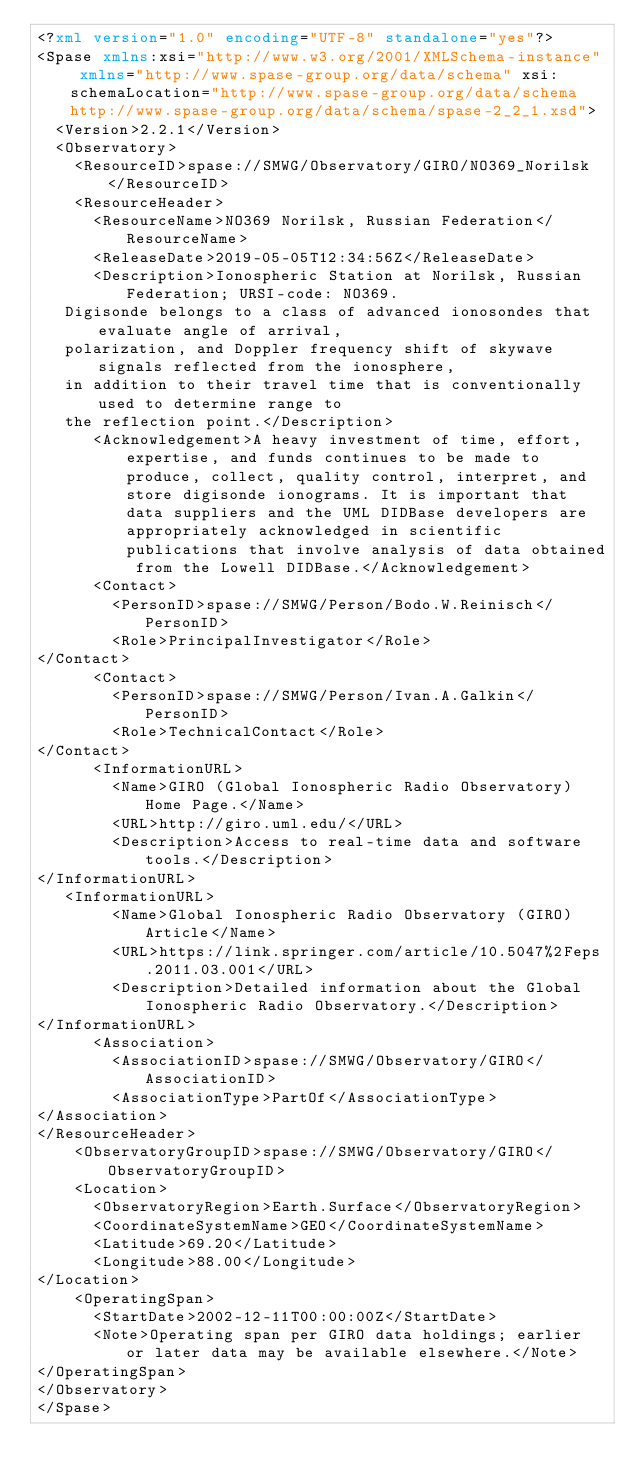<code> <loc_0><loc_0><loc_500><loc_500><_XML_><?xml version="1.0" encoding="UTF-8" standalone="yes"?>
<Spase xmlns:xsi="http://www.w3.org/2001/XMLSchema-instance" xmlns="http://www.spase-group.org/data/schema" xsi:schemaLocation="http://www.spase-group.org/data/schema http://www.spase-group.org/data/schema/spase-2_2_1.xsd">
  <Version>2.2.1</Version>
  <Observatory>
    <ResourceID>spase://SMWG/Observatory/GIRO/NO369_Norilsk</ResourceID>
    <ResourceHeader>
      <ResourceName>NO369 Norilsk, Russian Federation</ResourceName>
      <ReleaseDate>2019-05-05T12:34:56Z</ReleaseDate>
      <Description>Ionospheric Station at Norilsk, Russian Federation; URSI-code: NO369.
   Digisonde belongs to a class of advanced ionosondes that evaluate angle of arrival,
   polarization, and Doppler frequency shift of skywave signals reflected from the ionosphere,
   in addition to their travel time that is conventionally used to determine range to
   the reflection point.</Description>
      <Acknowledgement>A heavy investment of time, effort, expertise, and funds continues to be made to produce, collect, quality control, interpret, and store digisonde ionograms. It is important that data suppliers and the UML DIDBase developers are appropriately acknowledged in scientific publications that involve analysis of data obtained from the Lowell DIDBase.</Acknowledgement>
      <Contact>
        <PersonID>spase://SMWG/Person/Bodo.W.Reinisch</PersonID>
        <Role>PrincipalInvestigator</Role>
</Contact>
      <Contact>
        <PersonID>spase://SMWG/Person/Ivan.A.Galkin</PersonID>
        <Role>TechnicalContact</Role>
</Contact>
      <InformationURL>
        <Name>GIRO (Global Ionospheric Radio Observatory) Home Page.</Name>
        <URL>http://giro.uml.edu/</URL>
        <Description>Access to real-time data and software tools.</Description>
</InformationURL>
   <InformationURL>
        <Name>Global Ionospheric Radio Observatory (GIRO) Article</Name>
        <URL>https://link.springer.com/article/10.5047%2Feps.2011.03.001</URL>
        <Description>Detailed information about the Global Ionospheric Radio Observatory.</Description>
</InformationURL>
      <Association>
        <AssociationID>spase://SMWG/Observatory/GIRO</AssociationID>
        <AssociationType>PartOf</AssociationType>
</Association>
</ResourceHeader>
    <ObservatoryGroupID>spase://SMWG/Observatory/GIRO</ObservatoryGroupID>
    <Location>
      <ObservatoryRegion>Earth.Surface</ObservatoryRegion>
      <CoordinateSystemName>GEO</CoordinateSystemName>
      <Latitude>69.20</Latitude>
      <Longitude>88.00</Longitude>
</Location>
    <OperatingSpan>
      <StartDate>2002-12-11T00:00:00Z</StartDate>
      <Note>Operating span per GIRO data holdings; earlier or later data may be available elsewhere.</Note>
</OperatingSpan>
</Observatory>
</Spase>

</code> 